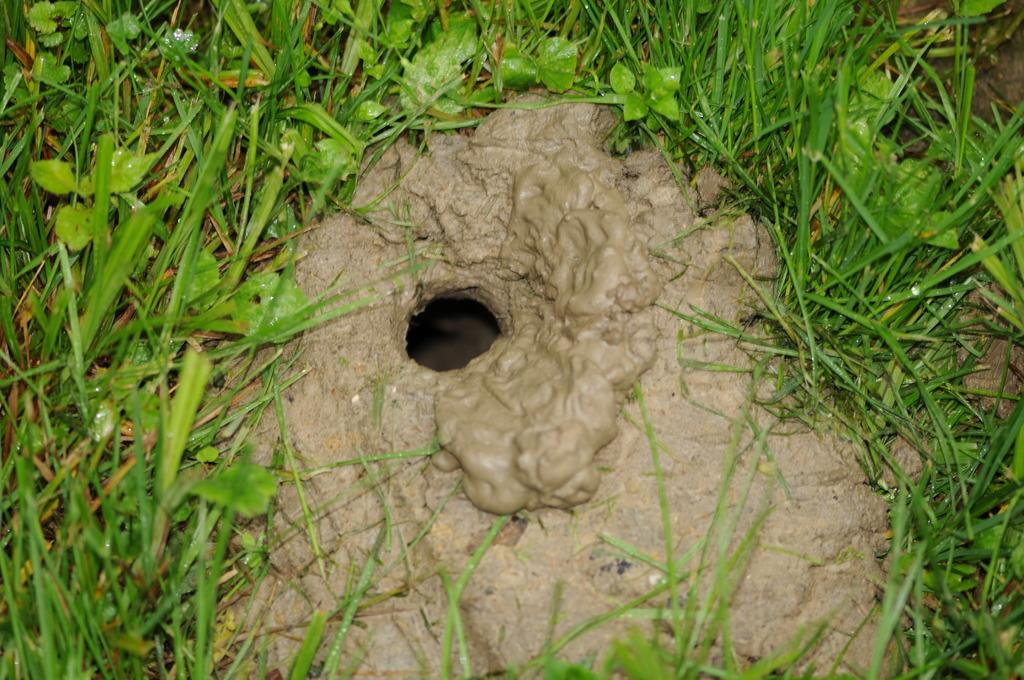What is the main feature of the image? There is a hole in the mud in the image. What type of vegetation is visible around the hole? Grass is present on the surface around the hole. How does the crowd react to the cheese in the image? There is no crowd or cheese present in the image. What type of thing is visible in the hole in the image? The facts provided do not specify what is inside the hole, so we cannot determine the type of thing visible in the hole. 